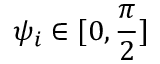<formula> <loc_0><loc_0><loc_500><loc_500>\psi _ { i } \in [ 0 , \frac { \pi } { 2 } ]</formula> 